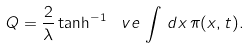Convert formula to latex. <formula><loc_0><loc_0><loc_500><loc_500>Q = \frac { 2 } { \lambda } \tanh ^ { - 1 } \, \ v e \, \int \, d x \, \pi ( x , t ) .</formula> 